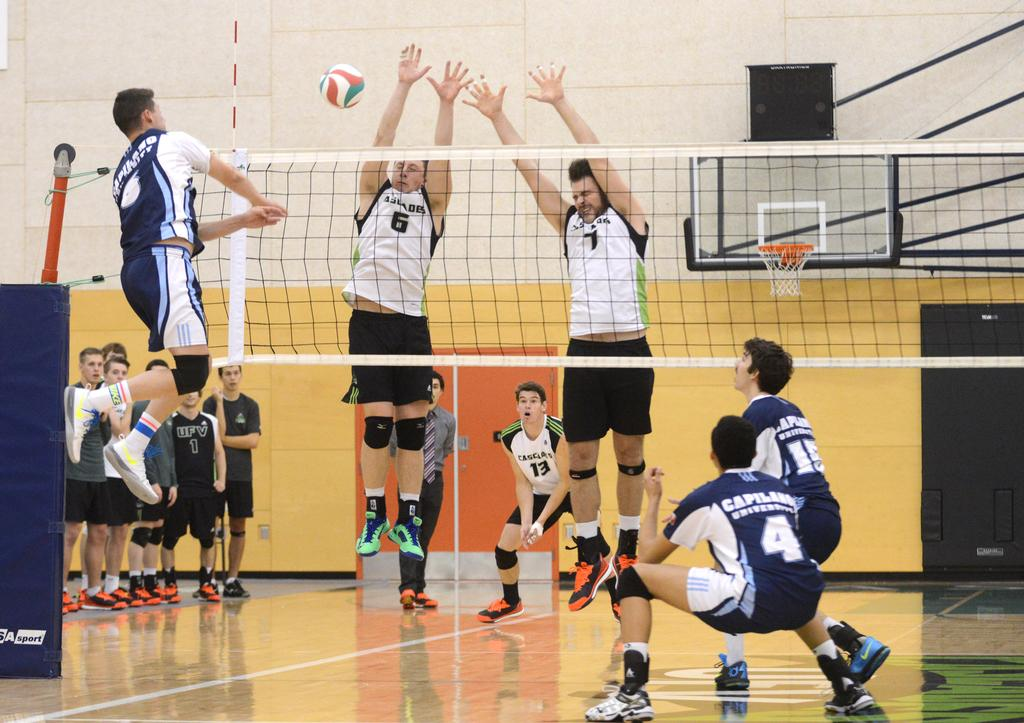What type of surface can be seen in the image? There is ground visible in the image. What are the persons in the image doing? There are persons jumping and standing in the image. What object is present in the image that is commonly used in sports? There is a ball in the image. What can be seen in the background of the image? There is a wall, a basketball goal post, and a black colored object in the background of the image. Where is the library located in the image? There is no library present in the image. What type of toothbrush is being used by the persons in the image? There is no toothbrush visible in the image. 